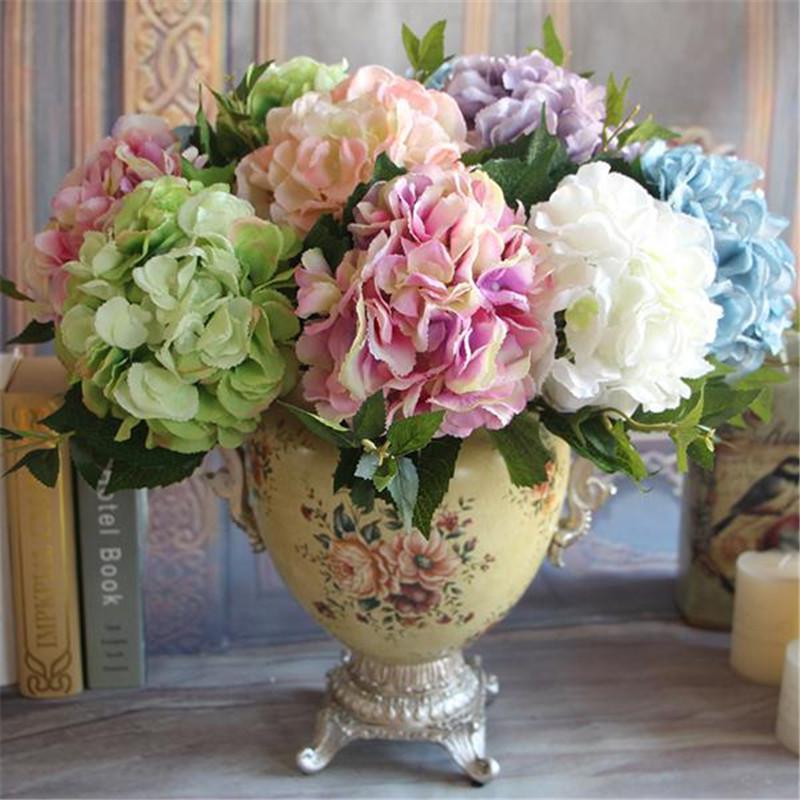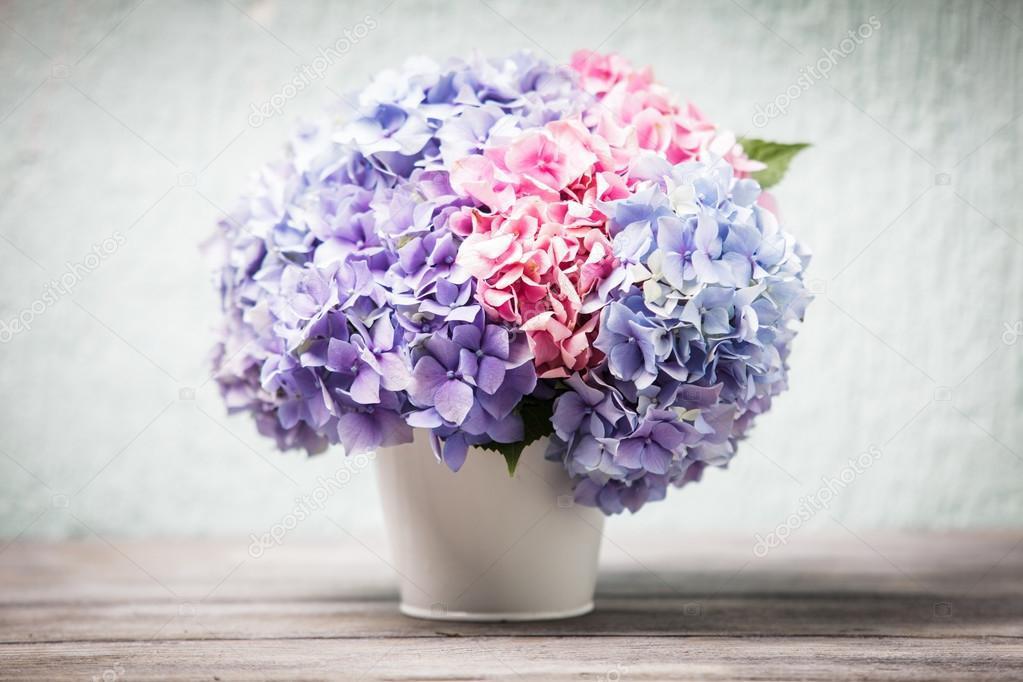The first image is the image on the left, the second image is the image on the right. Assess this claim about the two images: "One of the floral arrangements has only blue flowers.". Correct or not? Answer yes or no. No. 